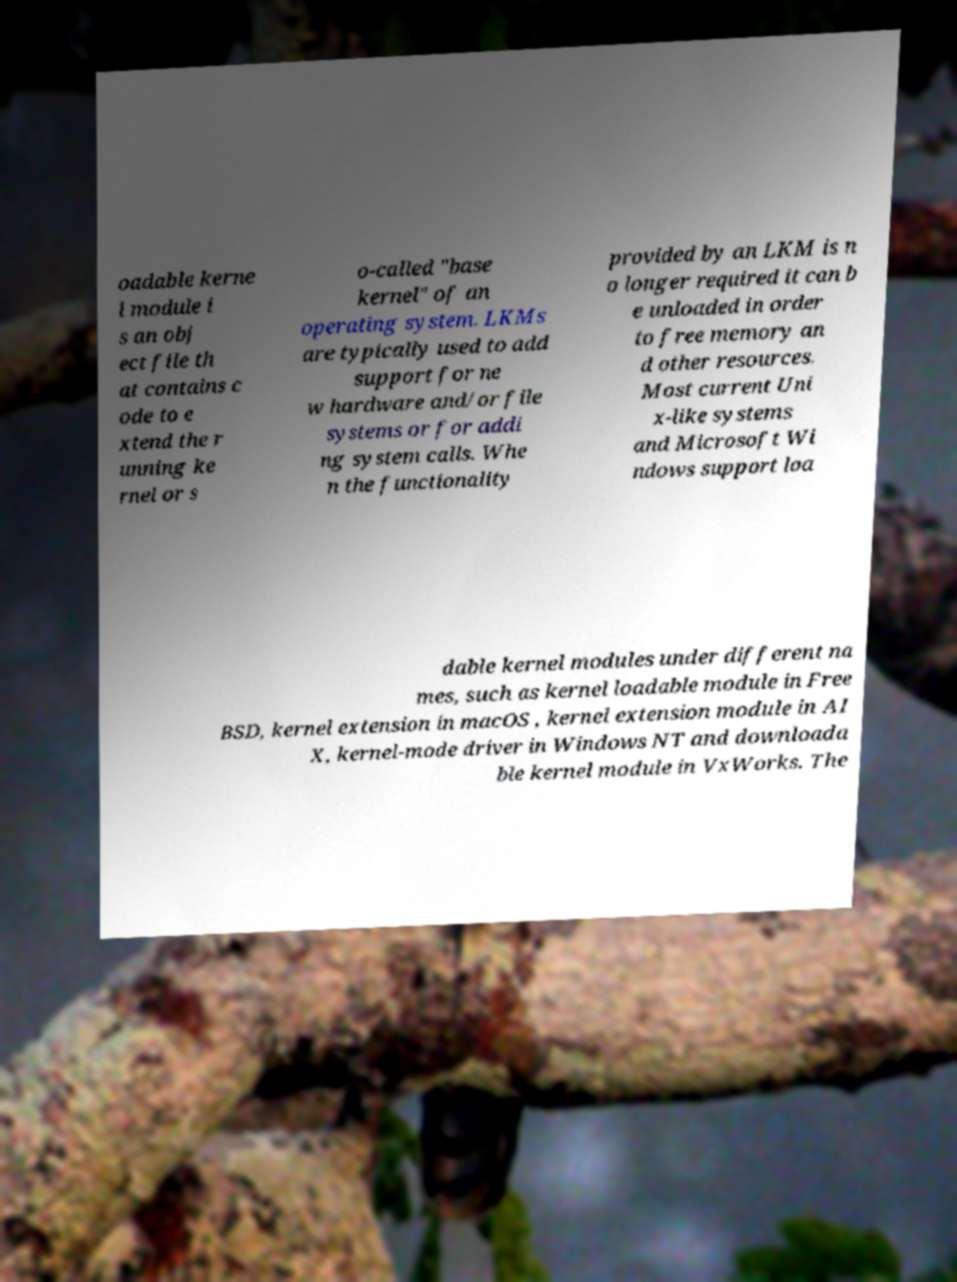I need the written content from this picture converted into text. Can you do that? oadable kerne l module i s an obj ect file th at contains c ode to e xtend the r unning ke rnel or s o-called "base kernel" of an operating system. LKMs are typically used to add support for ne w hardware and/or file systems or for addi ng system calls. Whe n the functionality provided by an LKM is n o longer required it can b e unloaded in order to free memory an d other resources. Most current Uni x-like systems and Microsoft Wi ndows support loa dable kernel modules under different na mes, such as kernel loadable module in Free BSD, kernel extension in macOS , kernel extension module in AI X, kernel-mode driver in Windows NT and downloada ble kernel module in VxWorks. The 